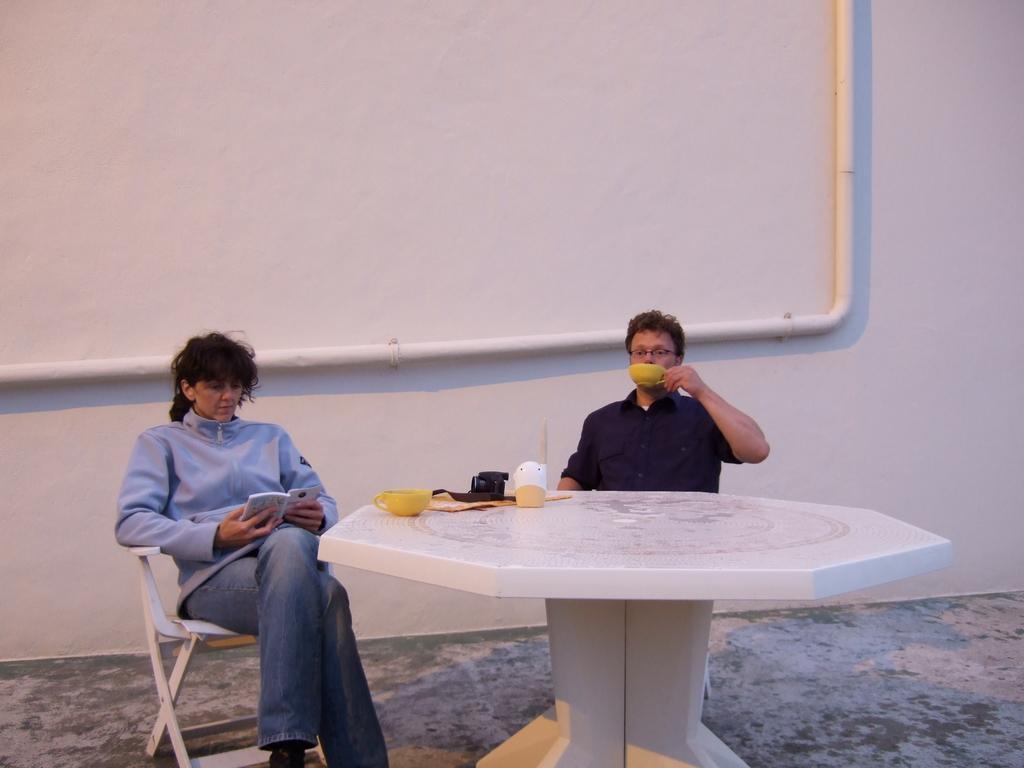Can you describe this image briefly? In the image we can see there are two people who are sitting on chair. 